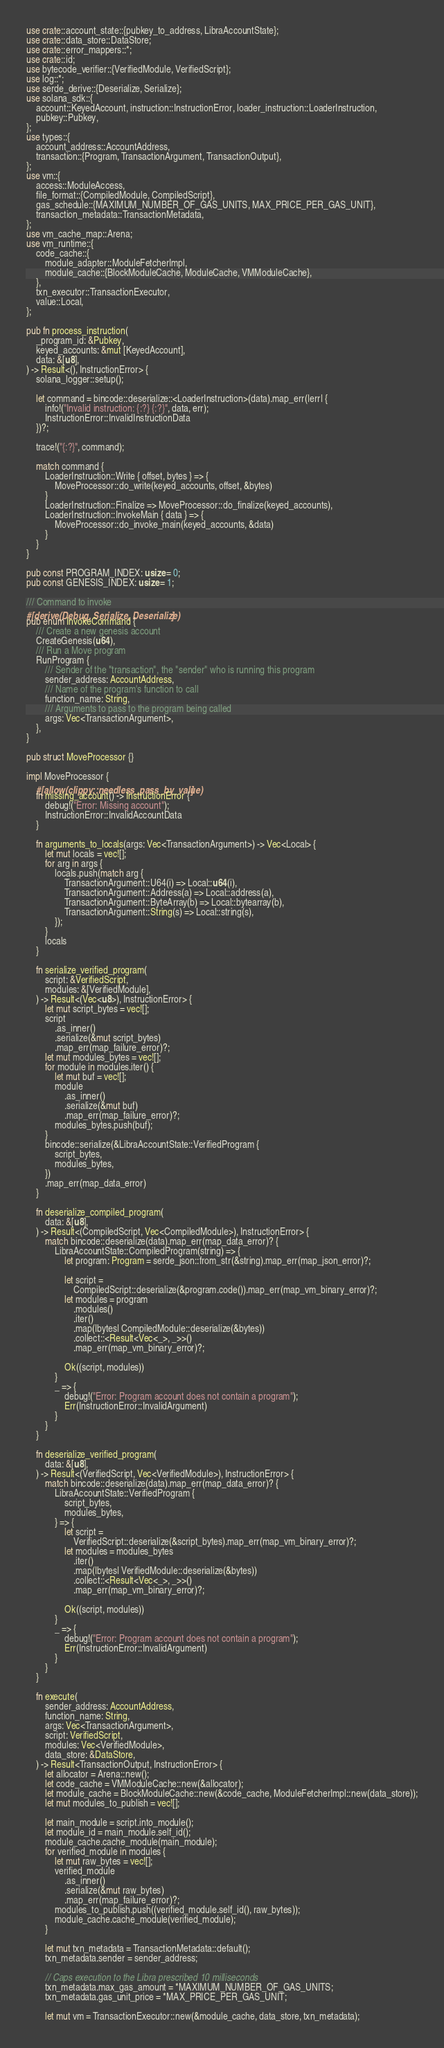Convert code to text. <code><loc_0><loc_0><loc_500><loc_500><_Rust_>use crate::account_state::{pubkey_to_address, LibraAccountState};
use crate::data_store::DataStore;
use crate::error_mappers::*;
use crate::id;
use bytecode_verifier::{VerifiedModule, VerifiedScript};
use log::*;
use serde_derive::{Deserialize, Serialize};
use solana_sdk::{
    account::KeyedAccount, instruction::InstructionError, loader_instruction::LoaderInstruction,
    pubkey::Pubkey,
};
use types::{
    account_address::AccountAddress,
    transaction::{Program, TransactionArgument, TransactionOutput},
};
use vm::{
    access::ModuleAccess,
    file_format::{CompiledModule, CompiledScript},
    gas_schedule::{MAXIMUM_NUMBER_OF_GAS_UNITS, MAX_PRICE_PER_GAS_UNIT},
    transaction_metadata::TransactionMetadata,
};
use vm_cache_map::Arena;
use vm_runtime::{
    code_cache::{
        module_adapter::ModuleFetcherImpl,
        module_cache::{BlockModuleCache, ModuleCache, VMModuleCache},
    },
    txn_executor::TransactionExecutor,
    value::Local,
};

pub fn process_instruction(
    _program_id: &Pubkey,
    keyed_accounts: &mut [KeyedAccount],
    data: &[u8],
) -> Result<(), InstructionError> {
    solana_logger::setup();

    let command = bincode::deserialize::<LoaderInstruction>(data).map_err(|err| {
        info!("Invalid instruction: {:?} {:?}", data, err);
        InstructionError::InvalidInstructionData
    })?;

    trace!("{:?}", command);

    match command {
        LoaderInstruction::Write { offset, bytes } => {
            MoveProcessor::do_write(keyed_accounts, offset, &bytes)
        }
        LoaderInstruction::Finalize => MoveProcessor::do_finalize(keyed_accounts),
        LoaderInstruction::InvokeMain { data } => {
            MoveProcessor::do_invoke_main(keyed_accounts, &data)
        }
    }
}

pub const PROGRAM_INDEX: usize = 0;
pub const GENESIS_INDEX: usize = 1;

/// Command to invoke
#[derive(Debug, Serialize, Deserialize)]
pub enum InvokeCommand {
    /// Create a new genesis account
    CreateGenesis(u64),
    /// Run a Move program
    RunProgram {
        /// Sender of the "transaction", the "sender" who is running this program
        sender_address: AccountAddress,
        /// Name of the program's function to call
        function_name: String,
        /// Arguments to pass to the program being called
        args: Vec<TransactionArgument>,
    },
}

pub struct MoveProcessor {}

impl MoveProcessor {
    #[allow(clippy::needless_pass_by_value)]
    fn missing_account() -> InstructionError {
        debug!("Error: Missing account");
        InstructionError::InvalidAccountData
    }

    fn arguments_to_locals(args: Vec<TransactionArgument>) -> Vec<Local> {
        let mut locals = vec![];
        for arg in args {
            locals.push(match arg {
                TransactionArgument::U64(i) => Local::u64(i),
                TransactionArgument::Address(a) => Local::address(a),
                TransactionArgument::ByteArray(b) => Local::bytearray(b),
                TransactionArgument::String(s) => Local::string(s),
            });
        }
        locals
    }

    fn serialize_verified_program(
        script: &VerifiedScript,
        modules: &[VerifiedModule],
    ) -> Result<(Vec<u8>), InstructionError> {
        let mut script_bytes = vec![];
        script
            .as_inner()
            .serialize(&mut script_bytes)
            .map_err(map_failure_error)?;
        let mut modules_bytes = vec![];
        for module in modules.iter() {
            let mut buf = vec![];
            module
                .as_inner()
                .serialize(&mut buf)
                .map_err(map_failure_error)?;
            modules_bytes.push(buf);
        }
        bincode::serialize(&LibraAccountState::VerifiedProgram {
            script_bytes,
            modules_bytes,
        })
        .map_err(map_data_error)
    }

    fn deserialize_compiled_program(
        data: &[u8],
    ) -> Result<(CompiledScript, Vec<CompiledModule>), InstructionError> {
        match bincode::deserialize(data).map_err(map_data_error)? {
            LibraAccountState::CompiledProgram(string) => {
                let program: Program = serde_json::from_str(&string).map_err(map_json_error)?;

                let script =
                    CompiledScript::deserialize(&program.code()).map_err(map_vm_binary_error)?;
                let modules = program
                    .modules()
                    .iter()
                    .map(|bytes| CompiledModule::deserialize(&bytes))
                    .collect::<Result<Vec<_>, _>>()
                    .map_err(map_vm_binary_error)?;

                Ok((script, modules))
            }
            _ => {
                debug!("Error: Program account does not contain a program");
                Err(InstructionError::InvalidArgument)
            }
        }
    }

    fn deserialize_verified_program(
        data: &[u8],
    ) -> Result<(VerifiedScript, Vec<VerifiedModule>), InstructionError> {
        match bincode::deserialize(data).map_err(map_data_error)? {
            LibraAccountState::VerifiedProgram {
                script_bytes,
                modules_bytes,
            } => {
                let script =
                    VerifiedScript::deserialize(&script_bytes).map_err(map_vm_binary_error)?;
                let modules = modules_bytes
                    .iter()
                    .map(|bytes| VerifiedModule::deserialize(&bytes))
                    .collect::<Result<Vec<_>, _>>()
                    .map_err(map_vm_binary_error)?;

                Ok((script, modules))
            }
            _ => {
                debug!("Error: Program account does not contain a program");
                Err(InstructionError::InvalidArgument)
            }
        }
    }

    fn execute(
        sender_address: AccountAddress,
        function_name: String,
        args: Vec<TransactionArgument>,
        script: VerifiedScript,
        modules: Vec<VerifiedModule>,
        data_store: &DataStore,
    ) -> Result<TransactionOutput, InstructionError> {
        let allocator = Arena::new();
        let code_cache = VMModuleCache::new(&allocator);
        let module_cache = BlockModuleCache::new(&code_cache, ModuleFetcherImpl::new(data_store));
        let mut modules_to_publish = vec![];

        let main_module = script.into_module();
        let module_id = main_module.self_id();
        module_cache.cache_module(main_module);
        for verified_module in modules {
            let mut raw_bytes = vec![];
            verified_module
                .as_inner()
                .serialize(&mut raw_bytes)
                .map_err(map_failure_error)?;
            modules_to_publish.push((verified_module.self_id(), raw_bytes));
            module_cache.cache_module(verified_module);
        }

        let mut txn_metadata = TransactionMetadata::default();
        txn_metadata.sender = sender_address;

        // Caps execution to the Libra prescribed 10 milliseconds
        txn_metadata.max_gas_amount = *MAXIMUM_NUMBER_OF_GAS_UNITS;
        txn_metadata.gas_unit_price = *MAX_PRICE_PER_GAS_UNIT;

        let mut vm = TransactionExecutor::new(&module_cache, data_store, txn_metadata);</code> 